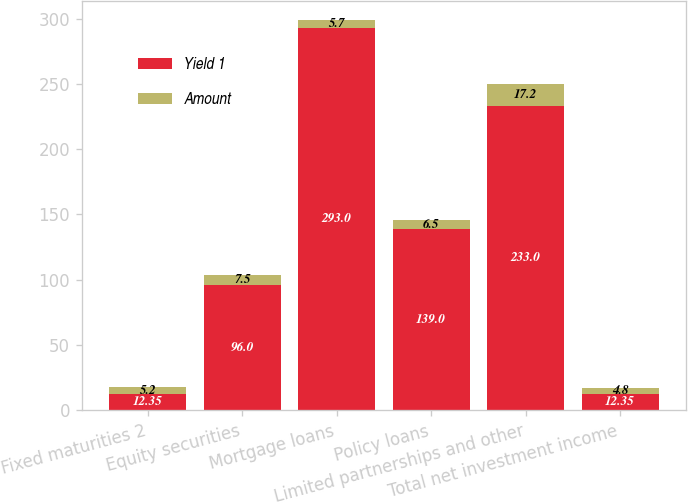Convert chart to OTSL. <chart><loc_0><loc_0><loc_500><loc_500><stacked_bar_chart><ecel><fcel>Fixed maturities 2<fcel>Equity securities<fcel>Mortgage loans<fcel>Policy loans<fcel>Limited partnerships and other<fcel>Total net investment income<nl><fcel>Yield 1<fcel>12.35<fcel>96<fcel>293<fcel>139<fcel>233<fcel>12.35<nl><fcel>Amount<fcel>5.2<fcel>7.5<fcel>5.7<fcel>6.5<fcel>17.2<fcel>4.8<nl></chart> 